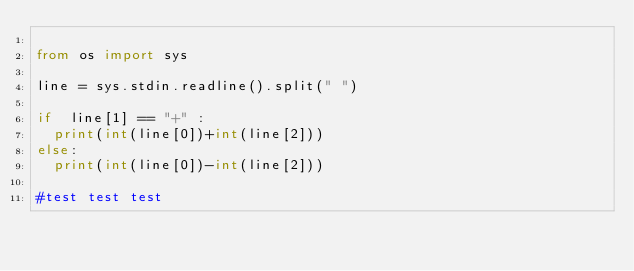<code> <loc_0><loc_0><loc_500><loc_500><_Python_>
from os import sys

line = sys.stdin.readline().split(" ")

if  line[1] == "+" :
  print(int(line[0])+int(line[2]))
else:
  print(int(line[0])-int(line[2]))
  
#test test test</code> 